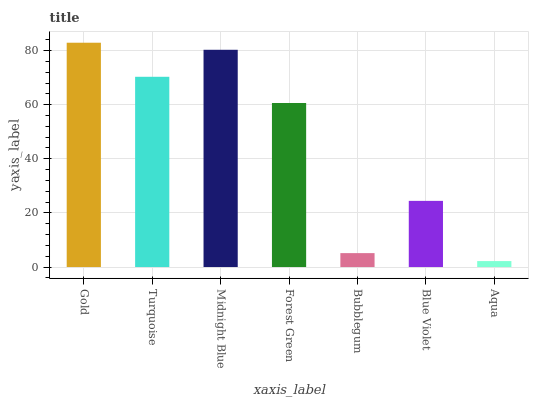Is Aqua the minimum?
Answer yes or no. Yes. Is Gold the maximum?
Answer yes or no. Yes. Is Turquoise the minimum?
Answer yes or no. No. Is Turquoise the maximum?
Answer yes or no. No. Is Gold greater than Turquoise?
Answer yes or no. Yes. Is Turquoise less than Gold?
Answer yes or no. Yes. Is Turquoise greater than Gold?
Answer yes or no. No. Is Gold less than Turquoise?
Answer yes or no. No. Is Forest Green the high median?
Answer yes or no. Yes. Is Forest Green the low median?
Answer yes or no. Yes. Is Blue Violet the high median?
Answer yes or no. No. Is Aqua the low median?
Answer yes or no. No. 